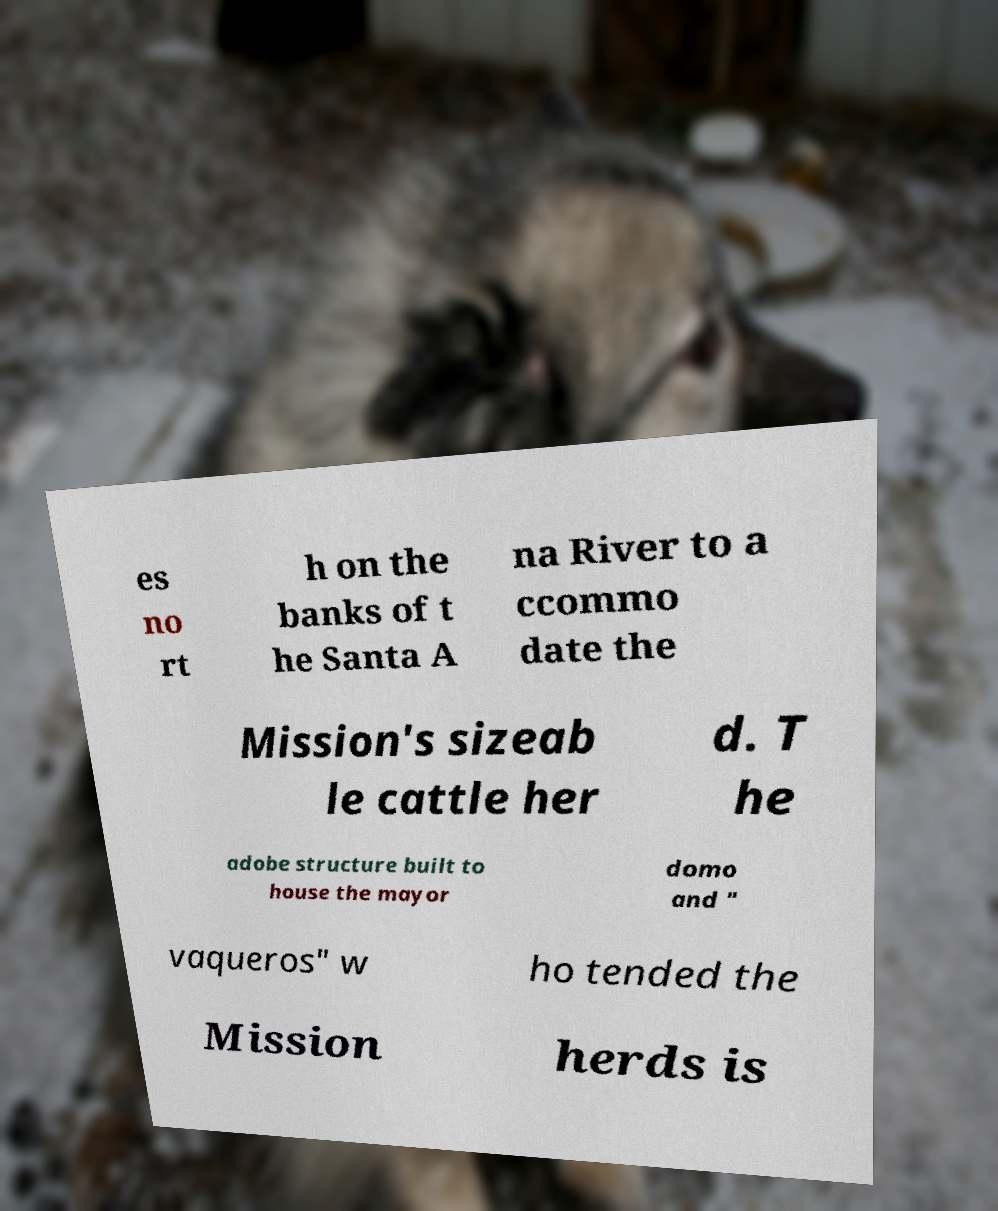There's text embedded in this image that I need extracted. Can you transcribe it verbatim? es no rt h on the banks of t he Santa A na River to a ccommo date the Mission's sizeab le cattle her d. T he adobe structure built to house the mayor domo and " vaqueros" w ho tended the Mission herds is 